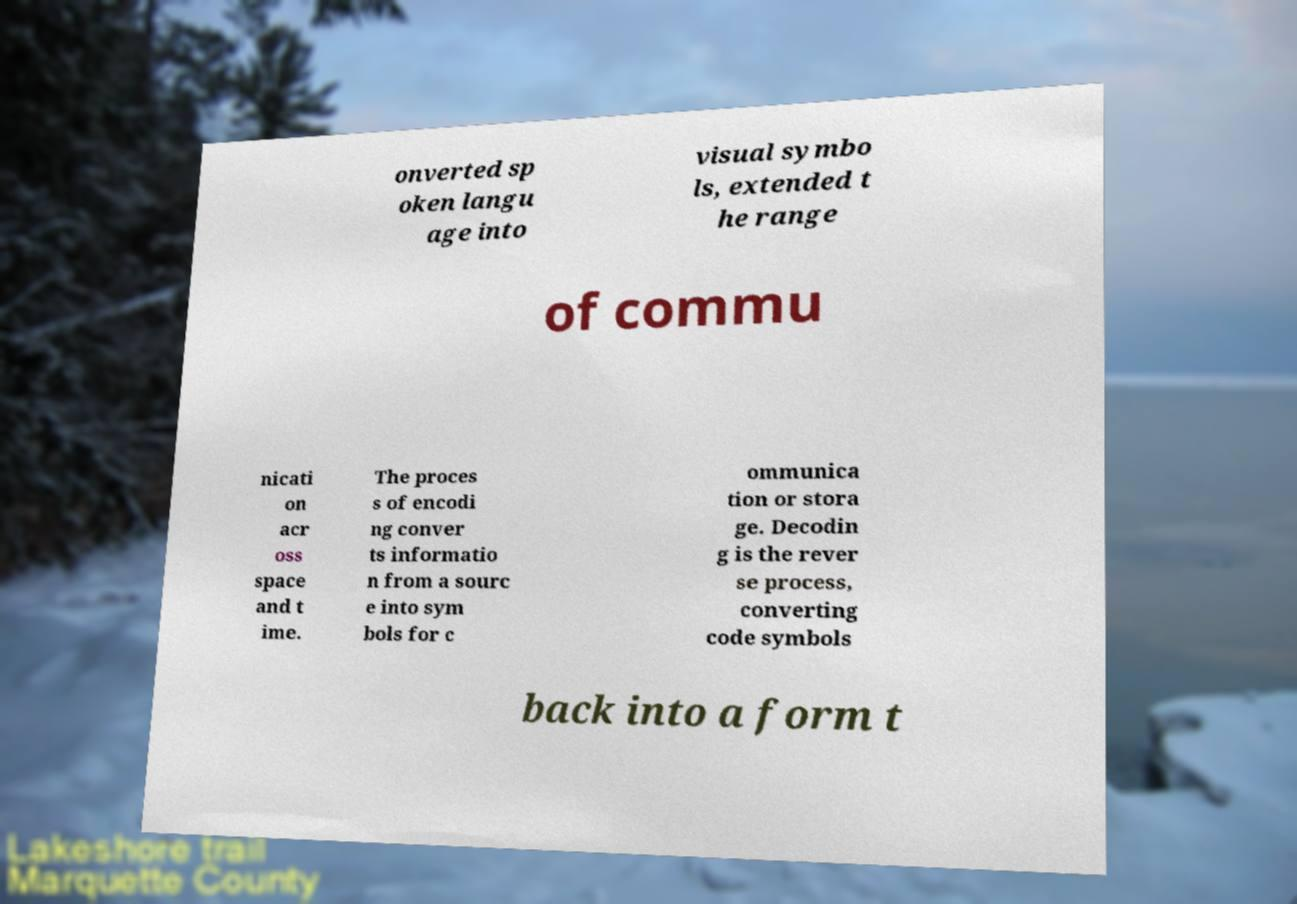What messages or text are displayed in this image? I need them in a readable, typed format. onverted sp oken langu age into visual symbo ls, extended t he range of commu nicati on acr oss space and t ime. The proces s of encodi ng conver ts informatio n from a sourc e into sym bols for c ommunica tion or stora ge. Decodin g is the rever se process, converting code symbols back into a form t 